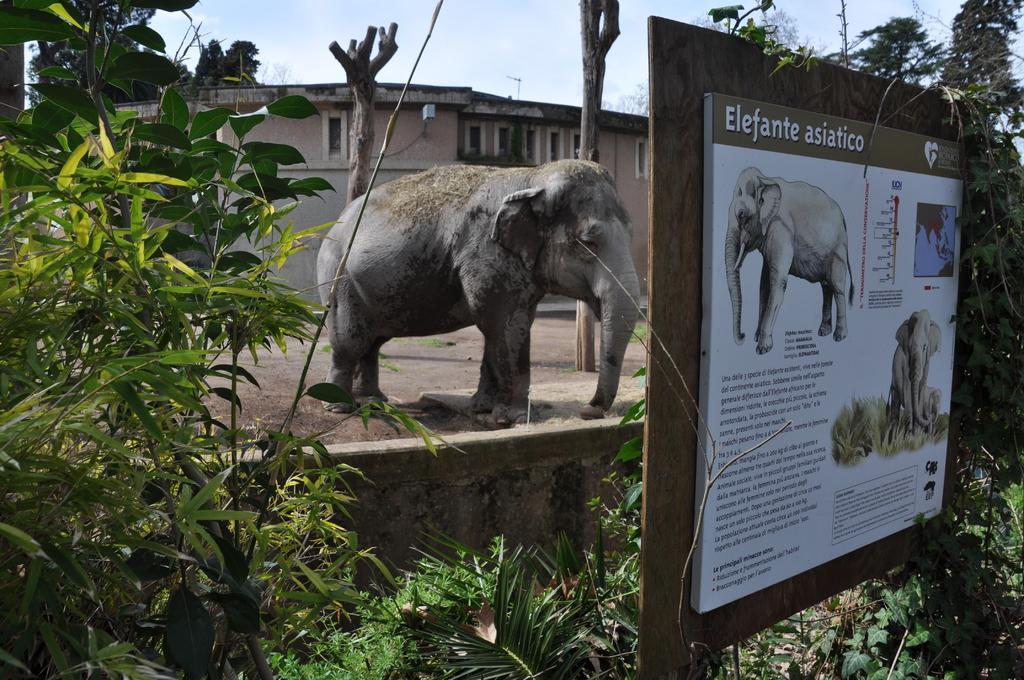In one or two sentences, can you explain what this image depicts? In this picture we can see a notice board, beside to the notice board we can find few trees, in the background we can see an elephant and a building. 